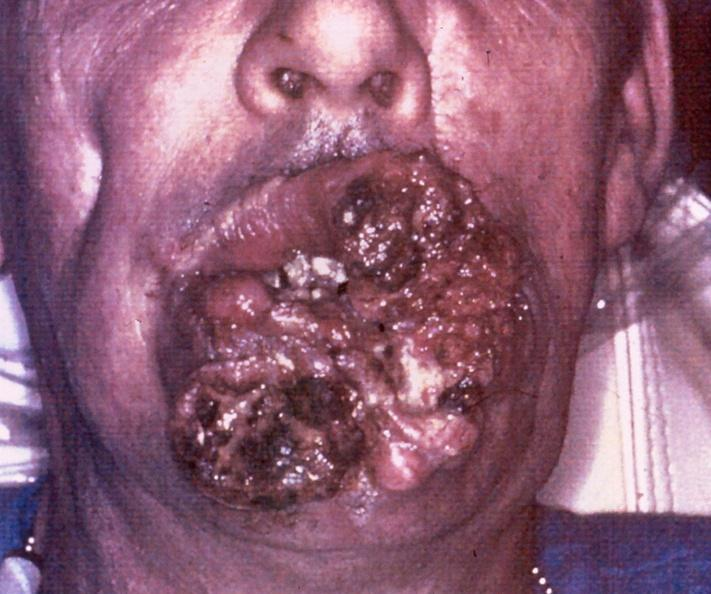what is present?
Answer the question using a single word or phrase. Gastrointestinal 